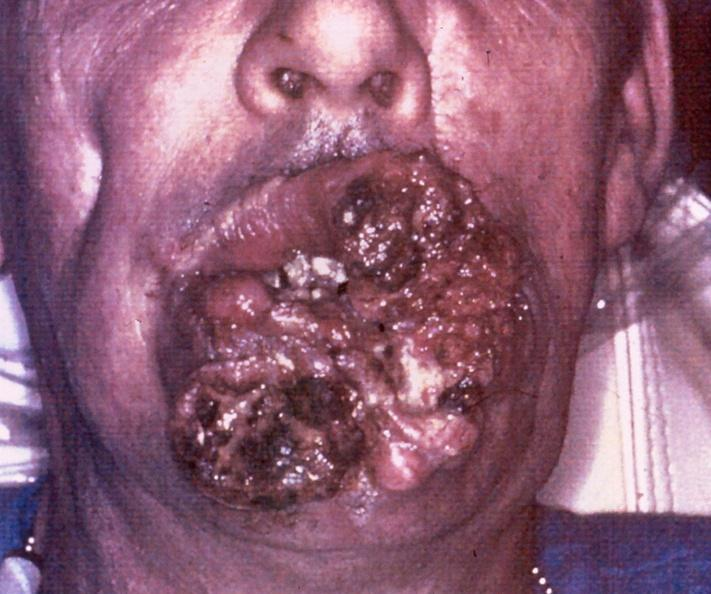what is present?
Answer the question using a single word or phrase. Gastrointestinal 